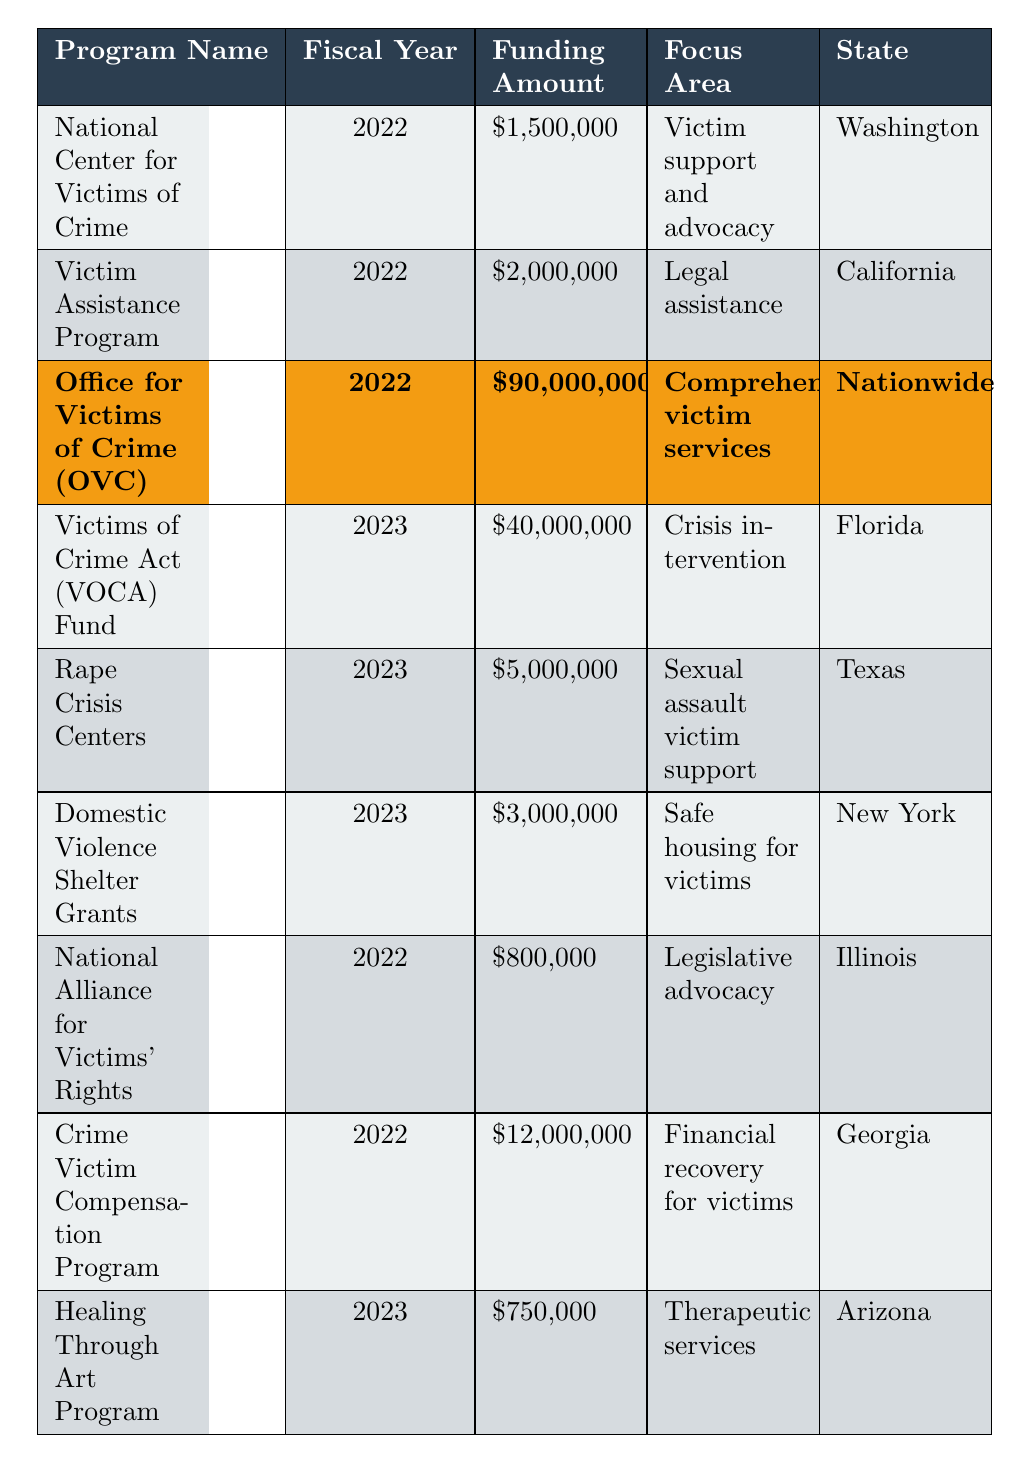What is the funding amount for the Office for Victims of Crime (OVC) program? The table shows that the funding amount for the Office for Victims of Crime (OVC) in 2022 is $90,000,000.
Answer: $90,000,000 Which state has the highest funding amount for victim advocacy programs listed in the table? By comparing the funding amounts, the Office for Victims of Crime (OVC), which serves nationwide, has the highest funding of $90,000,000.
Answer: Nationwide How much total funding was allocated in 2023? Adding the allocated amounts for 2023: $40,000,000 (VOCA Fund) + $5,000,000 (Rape Crisis Centers) + $3,000,000 (Domestic Violence Shelter Grants) + $750,000 (Healing Through Art Program) gives a total of $48,750,000.
Answer: $48,750,000 Is the National Center for Victims of Crime program focused on victim support and advocacy? Yes, according to the table, the focus area of the National Center for Victims of Crime is victim support and advocacy.
Answer: Yes What is the difference in funding between the 2022 Victim Assistance Program and the 2023 Rape Crisis Centers program? The Victim Assistance Program received $2,000,000 in 2022, and the Rape Crisis Centers received $5,000,000 in 2023. The difference is $5,000,000 - $2,000,000 = $3,000,000.
Answer: $3,000,000 What percentage of total funding for 2022 does the Crime Victim Compensation Program represent? The total funding for 2022 is $90,000,000 (OVC) + $2,000,000 (Victim Assistance) + $1,500,000 (National Center for Victims of Crime) + $12,000,000 (Crime Victim Compensation) + $800,000 (National Alliance for Victims' Rights) = $105,300,000. The percentage of the Crime Victim Compensation Program, which received $12,000,000, is ($12,000,000 / $105,300,000) * 100 ≈ 11.39%.
Answer: Approximately 11.39% Which program has a funding amount closest to $1 million? The Healing Through Art Program has a funding amount of $750,000, which is the closest to $1 million when looking at the funding figures in the table.
Answer: $750,000 How many programs received funding amounts over $5 million in the table? The programs that received over $5 million are: Office for Victims of Crime ($90 million), VOCA Fund ($40 million), Victim Assistance Program ($2 million), Crime Victim Compensation Program ($12 million). The count of programs over $5 million is four.
Answer: 4 Did any program receive funding in both 2022 and 2023? Based on the data, no program is mentioned to have received funding in both 2022 and 2023, indicating that they are all distinct programs and years.
Answer: No 